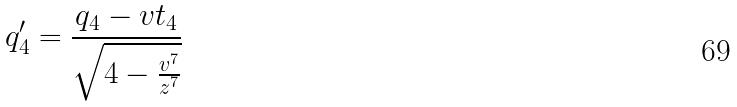<formula> <loc_0><loc_0><loc_500><loc_500>q _ { 4 } ^ { \prime } = \frac { q _ { 4 } - v t _ { 4 } } { \sqrt { 4 - \frac { v ^ { 7 } } { z ^ { 7 } } } }</formula> 